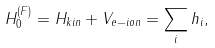<formula> <loc_0><loc_0><loc_500><loc_500>H _ { 0 } ^ { ( F ) } = H _ { k i n } + V _ { e - i o n } = \sum _ { i } h _ { i } ,</formula> 